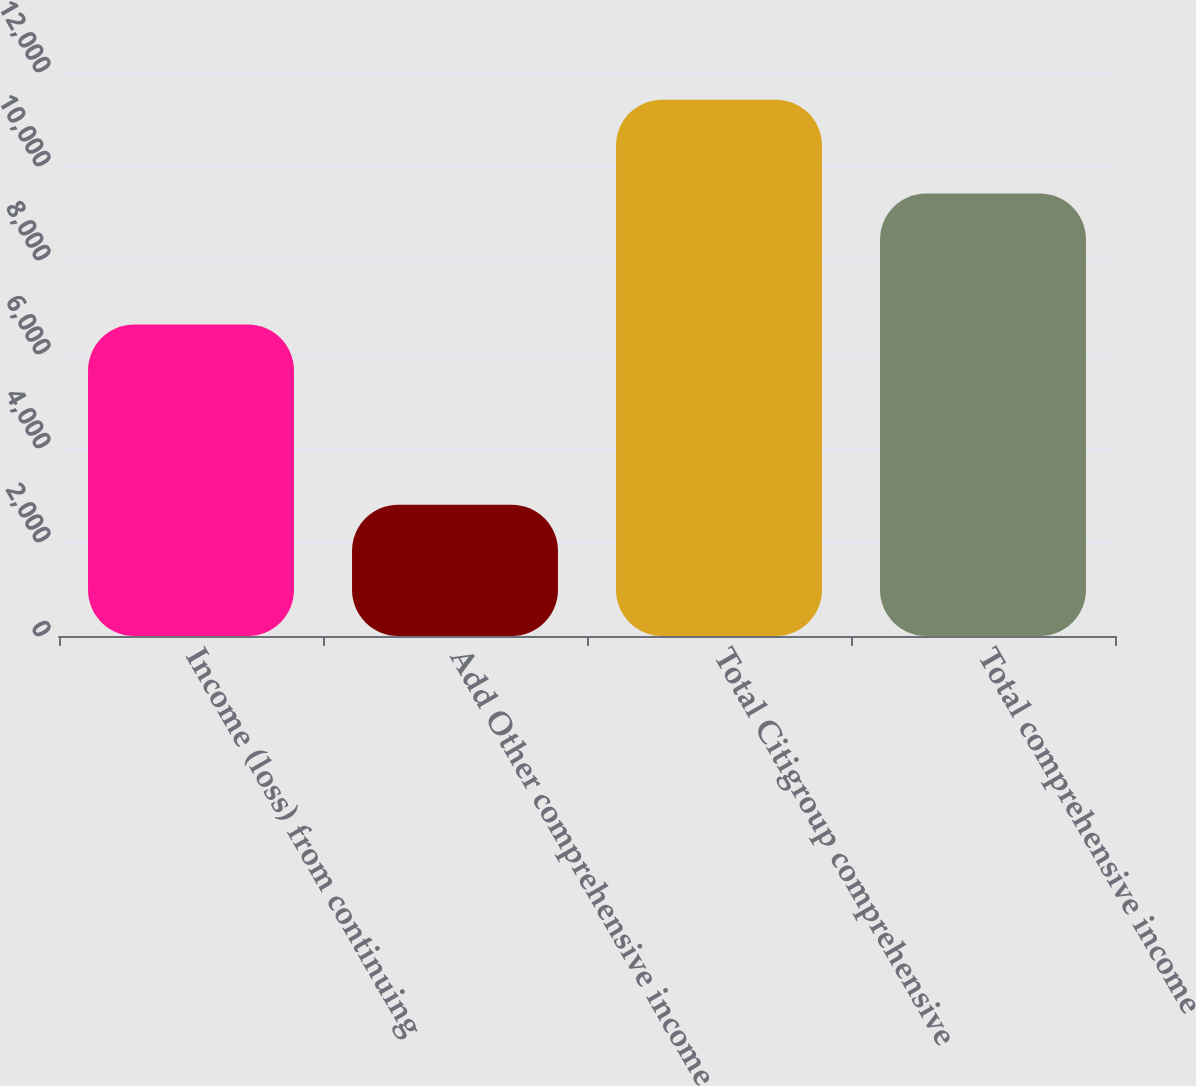Convert chart to OTSL. <chart><loc_0><loc_0><loc_500><loc_500><bar_chart><fcel>Income (loss) from continuing<fcel>Add Other comprehensive income<fcel>Total Citigroup comprehensive<fcel>Total comprehensive income<nl><fcel>6627<fcel>2791<fcel>11412<fcel>9415<nl></chart> 